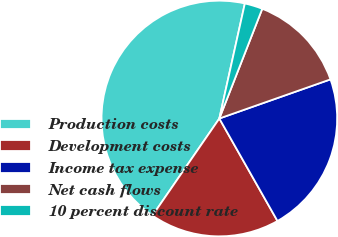Convert chart to OTSL. <chart><loc_0><loc_0><loc_500><loc_500><pie_chart><fcel>Production costs<fcel>Development costs<fcel>Income tax expense<fcel>Net cash flows<fcel>10 percent discount rate<nl><fcel>43.88%<fcel>17.82%<fcel>22.18%<fcel>13.68%<fcel>2.46%<nl></chart> 